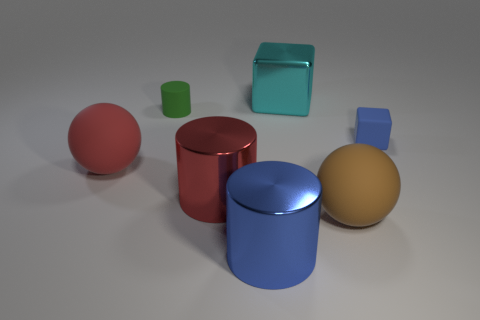Subtract all blue metallic cylinders. How many cylinders are left? 2 Add 1 gray spheres. How many objects exist? 8 Subtract all green balls. Subtract all blue blocks. How many balls are left? 2 Subtract all red blocks. How many blue spheres are left? 0 Subtract all purple rubber balls. Subtract all big matte things. How many objects are left? 5 Add 3 large brown rubber things. How many large brown rubber things are left? 4 Add 2 red metallic objects. How many red metallic objects exist? 3 Subtract all cyan blocks. How many blocks are left? 1 Subtract 0 cyan cylinders. How many objects are left? 7 Subtract all cubes. How many objects are left? 5 